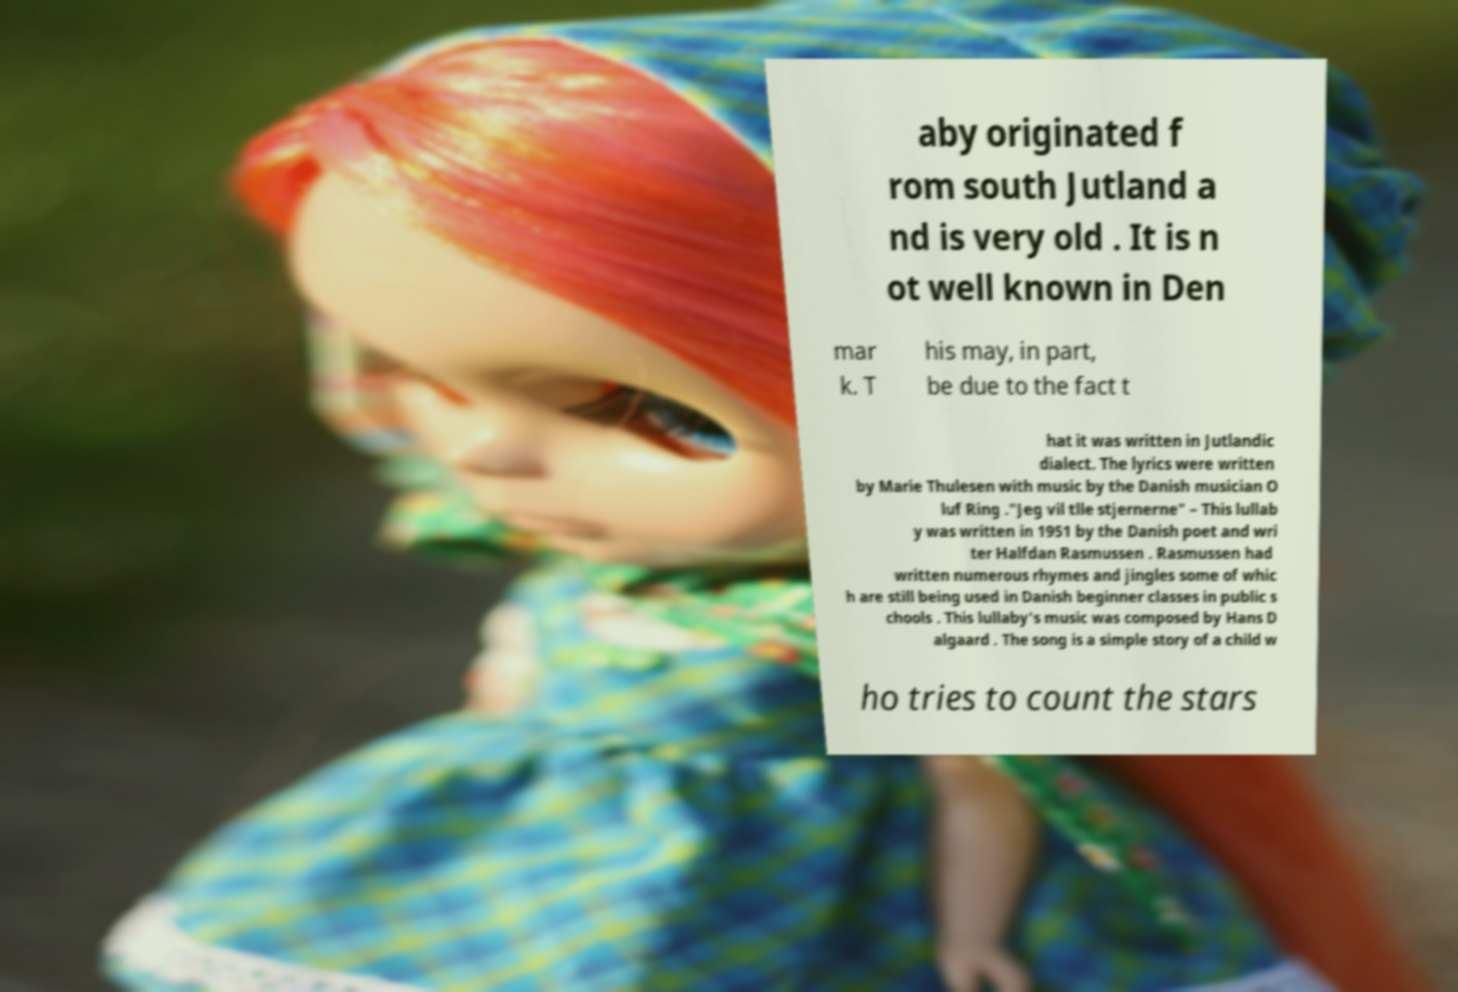Can you read and provide the text displayed in the image?This photo seems to have some interesting text. Can you extract and type it out for me? aby originated f rom south Jutland a nd is very old . It is n ot well known in Den mar k. T his may, in part, be due to the fact t hat it was written in Jutlandic dialect. The lyrics were written by Marie Thulesen with music by the Danish musician O luf Ring ."Jeg vil tlle stjernerne" – This lullab y was written in 1951 by the Danish poet and wri ter Halfdan Rasmussen . Rasmussen had written numerous rhymes and jingles some of whic h are still being used in Danish beginner classes in public s chools . This lullaby's music was composed by Hans D algaard . The song is a simple story of a child w ho tries to count the stars 